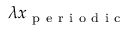Convert formula to latex. <formula><loc_0><loc_0><loc_500><loc_500>\lambda x _ { p e r i o d i c }</formula> 